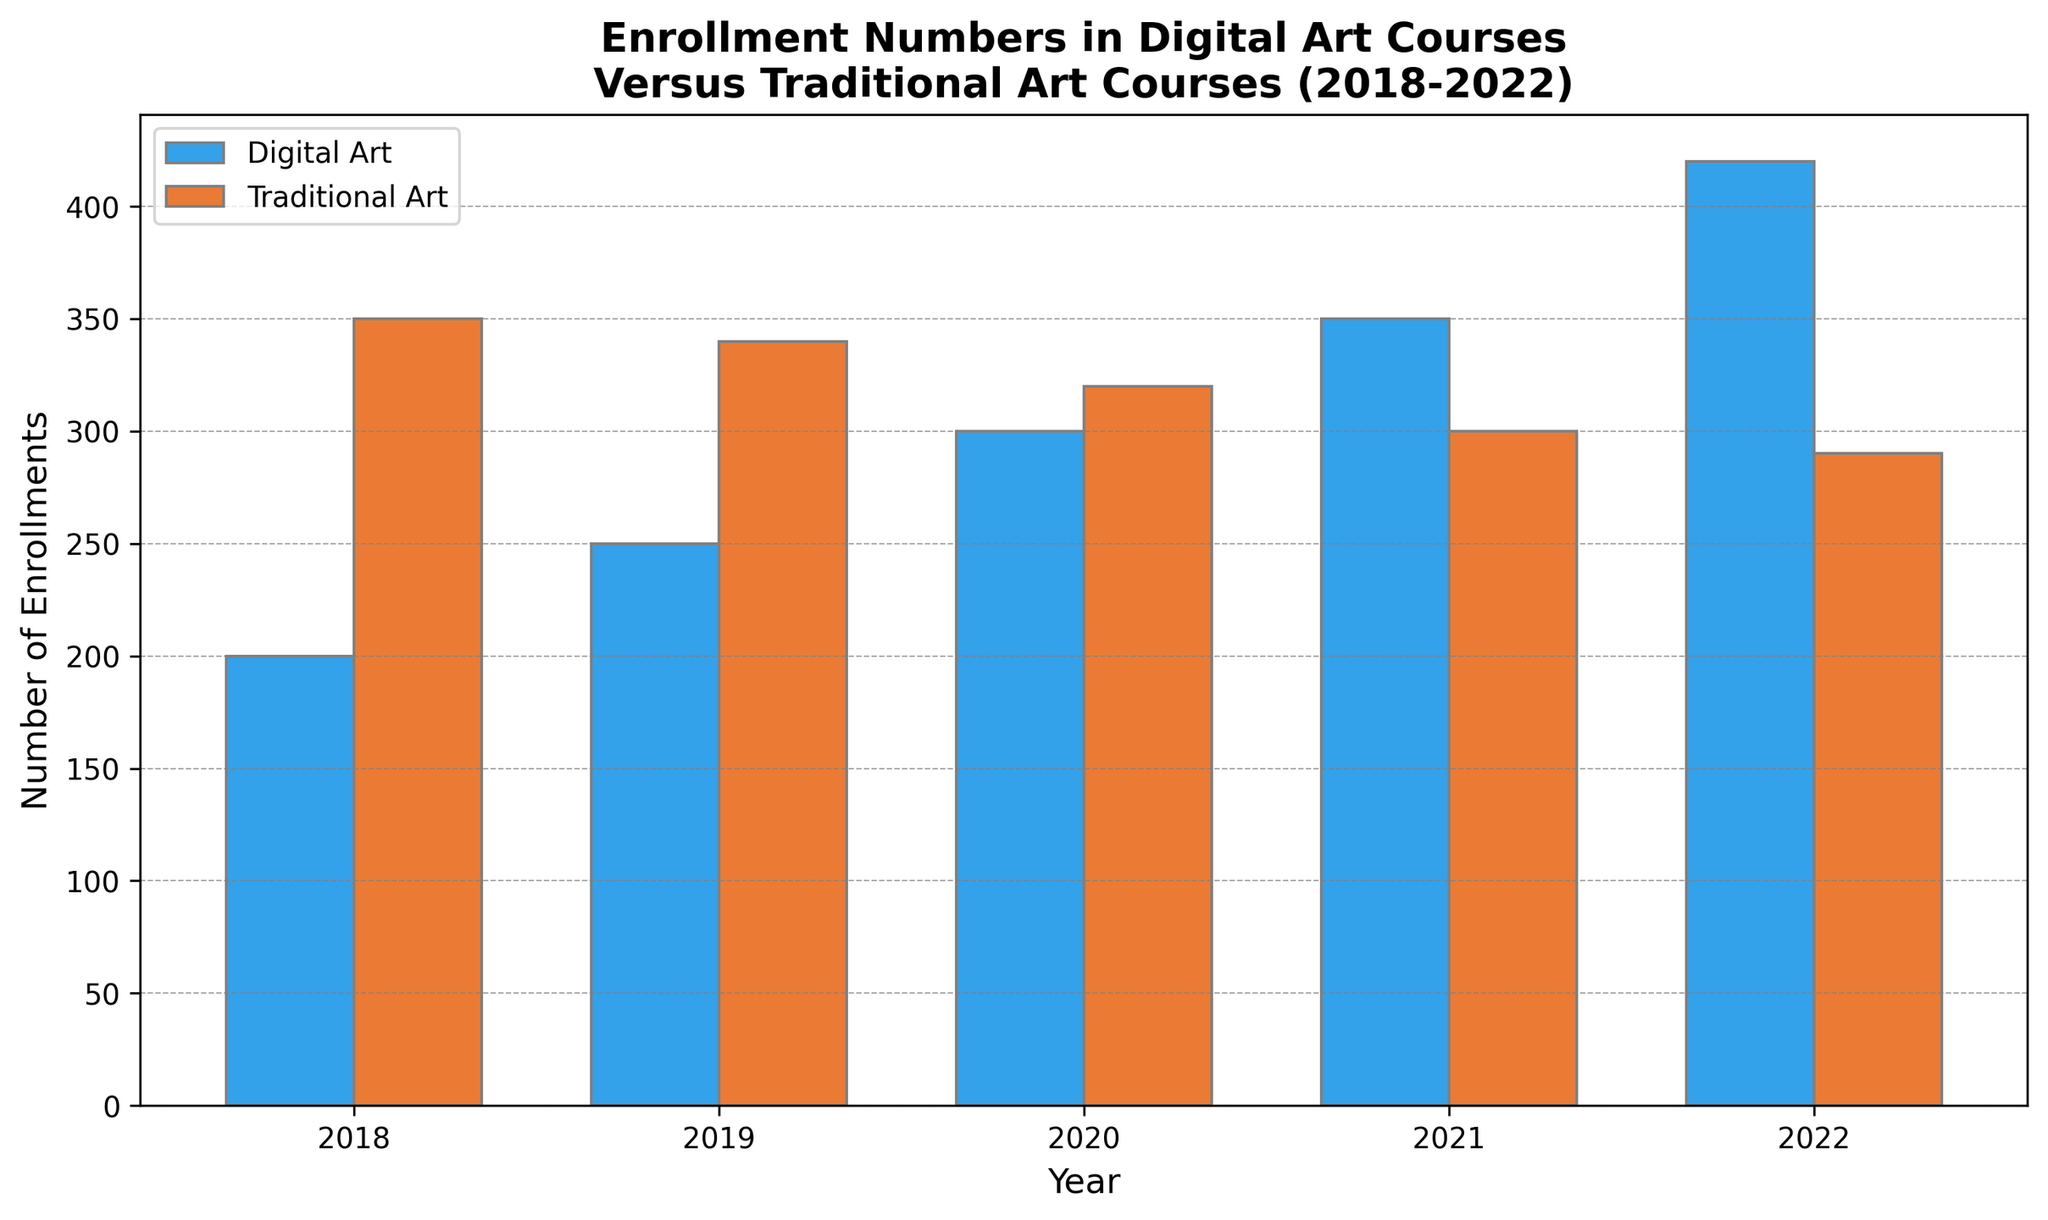What trend can be observed in the enrollment numbers of digital art courses from 2018 to 2022? Observing the bars for digital art courses, we see a consistent increase in the height of the bars from 2018 (200 enrollments) to 2022 (420 enrollments), indicating an upward trend.
Answer: An upward trend How do the enrollment numbers for traditional art courses in 2018 compare to those in 2022? Comparing the heights of the bars for traditional art in 2018 (350 enrollments) and 2022 (290 enrollments), it is evident that the enrollment numbers have decreased.
Answer: Decreased What was the largest difference in enrollments between digital art and traditional art courses in any given year? Calculating the absolute differences for each year: 2018 (350 - 200 = 150), 2019 (340 - 250 = 90), 2020 (320 - 300 = 20), 2021 (300 - 350 = 50), 2022 (420 - 290 = 130). The largest difference is 150 in 2018.
Answer: 150 in 2018 In which year did digital art enrollments surpass traditional art enrollments for the first time? Observing the heights of the bars for both courses across the years, digital art enrollments surpass traditional art enrollments for the first time in 2021.
Answer: 2021 What is the average enrollment in digital art courses over the 5-year span? Adding the enrollments for digital art for each year (200 + 250 + 300 + 350 + 420 = 1520) and then dividing by 5 years, we get 304.
Answer: 304 Which year had the smallest difference in enrollments between digital art and traditional art courses? Calculating the absolute differences for each year: 2018 (150), 2019 (90), 2020 (20), 2021 (50), 2022 (130). The smallest difference is 20 in 2020.
Answer: 2020 By how much did digital art enrollments increase from 2018 to 2022? Subtracting the digital art enrollments in 2018 from those in 2022: 420 - 200 = 220.
Answer: 220 How did the enrollments for traditional art courses change from 2019 to 2020? Comparing the heights of the bars for traditional art in 2019 (340 enrollments) and 2020 (320 enrollments), there was a decrease of 20 enrollments.
Answer: Decreased by 20 What is the overall trend for enrollments in traditional art courses over the 5-year period? Observing the heights of the bars for traditional art, there is a downward trend from 350 enrollments in 2018 to 290 enrollments in 2022.
Answer: Downward trend Compare the heights of the bars for digital art and traditional art in 2019. Which is taller? Observing the bars for 2019, the height of the bar for traditional art (340 enrollments) is taller than that for digital art (250 enrollments).
Answer: Traditional art 